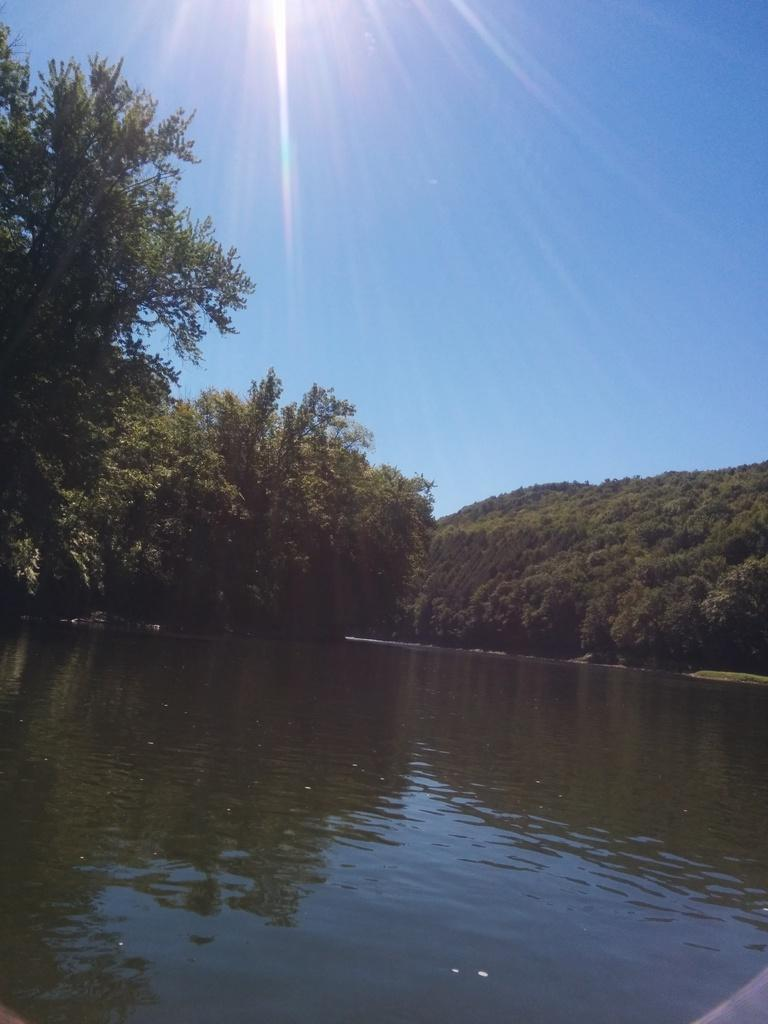What is visible in the image? There is water visible in the image. What can be seen behind the water? There is a group of trees behind the water. What is visible at the top of the image? The sky is visible at the top of the image. Where is the sofa located in the image? There is no sofa present in the image. How many trains can be seen in the image? There are no trains present in the image. 